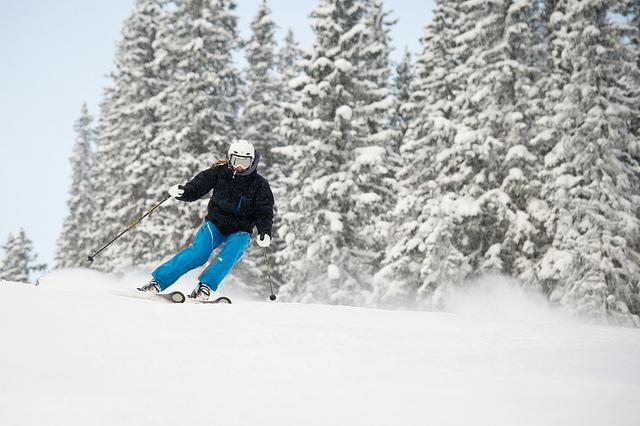Why is this person covering their face with gear?
Give a very brief answer. Cold. Are the trees covered in snow?
Concise answer only. Yes. Is there snow on the trees?
Keep it brief. Yes. 